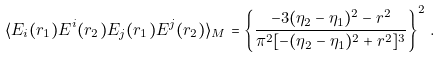Convert formula to latex. <formula><loc_0><loc_0><loc_500><loc_500>\langle E _ { i } ( r _ { 1 } ) E ^ { i } ( r _ { 2 } ) E _ { j } ( r _ { 1 } ) E ^ { j } ( r _ { 2 } ) \rangle _ { M } = \left \{ \frac { - 3 ( \eta _ { 2 } - \eta _ { 1 } ) ^ { 2 } - r ^ { 2 } } { \pi ^ { 2 } [ - ( \eta _ { 2 } - \eta _ { 1 } ) ^ { 2 } + r ^ { 2 } ] ^ { 3 } } \right \} ^ { 2 } \, .</formula> 